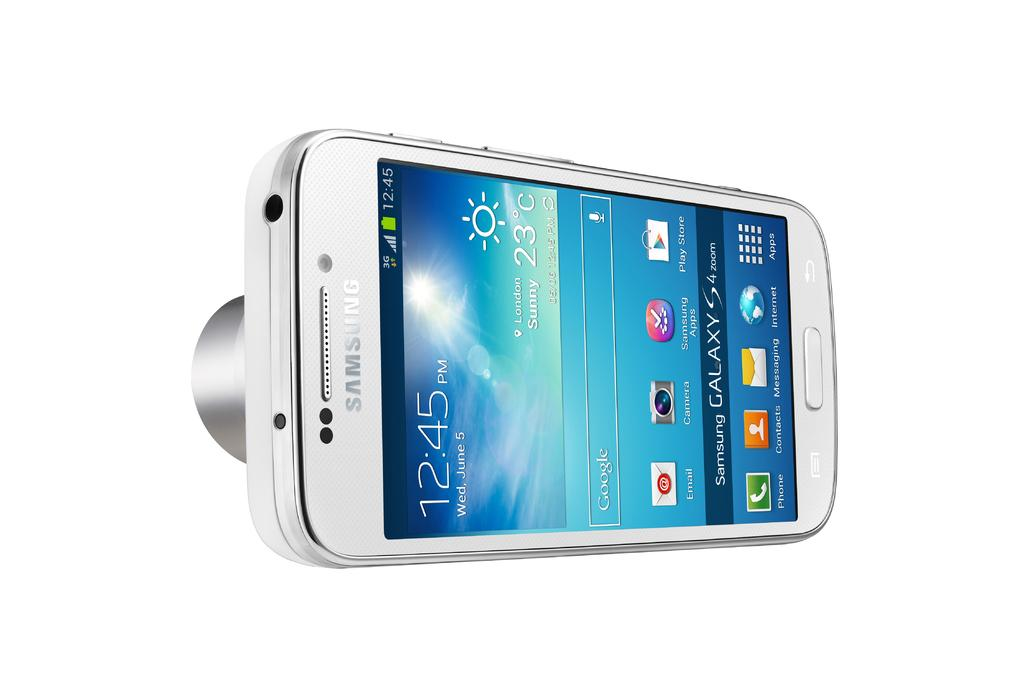<image>
Give a short and clear explanation of the subsequent image. A Samsung phone shows that the current time is 12:45 PM. 